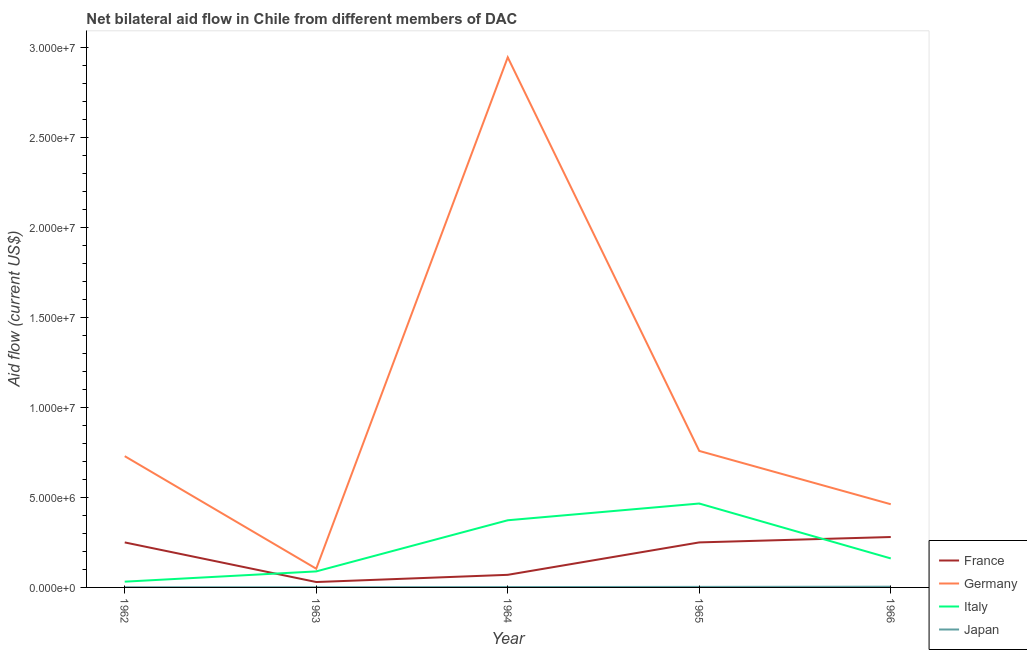Does the line corresponding to amount of aid given by italy intersect with the line corresponding to amount of aid given by germany?
Your answer should be very brief. No. Is the number of lines equal to the number of legend labels?
Ensure brevity in your answer.  Yes. What is the amount of aid given by japan in 1964?
Your answer should be very brief. 2.00e+04. Across all years, what is the maximum amount of aid given by japan?
Provide a succinct answer. 4.00e+04. Across all years, what is the minimum amount of aid given by japan?
Make the answer very short. 10000. In which year was the amount of aid given by france maximum?
Provide a succinct answer. 1966. In which year was the amount of aid given by germany minimum?
Give a very brief answer. 1963. What is the total amount of aid given by france in the graph?
Make the answer very short. 8.80e+06. What is the difference between the amount of aid given by france in 1962 and that in 1966?
Provide a succinct answer. -3.00e+05. What is the difference between the amount of aid given by germany in 1964 and the amount of aid given by italy in 1963?
Ensure brevity in your answer.  2.86e+07. What is the average amount of aid given by japan per year?
Provide a succinct answer. 2.20e+04. In the year 1966, what is the difference between the amount of aid given by france and amount of aid given by japan?
Provide a short and direct response. 2.76e+06. In how many years, is the amount of aid given by france greater than 9000000 US$?
Provide a succinct answer. 0. Is the amount of aid given by germany in 1963 less than that in 1965?
Make the answer very short. Yes. What is the difference between the highest and the second highest amount of aid given by italy?
Your response must be concise. 9.30e+05. What is the difference between the highest and the lowest amount of aid given by france?
Provide a short and direct response. 2.50e+06. In how many years, is the amount of aid given by france greater than the average amount of aid given by france taken over all years?
Ensure brevity in your answer.  3. Is the sum of the amount of aid given by france in 1963 and 1965 greater than the maximum amount of aid given by italy across all years?
Provide a short and direct response. No. Does the amount of aid given by italy monotonically increase over the years?
Your answer should be very brief. No. Is the amount of aid given by germany strictly greater than the amount of aid given by italy over the years?
Keep it short and to the point. Yes. How many lines are there?
Provide a succinct answer. 4. How many years are there in the graph?
Provide a short and direct response. 5. What is the difference between two consecutive major ticks on the Y-axis?
Your answer should be very brief. 5.00e+06. Are the values on the major ticks of Y-axis written in scientific E-notation?
Your answer should be very brief. Yes. Does the graph contain any zero values?
Keep it short and to the point. No. Does the graph contain grids?
Make the answer very short. No. How are the legend labels stacked?
Keep it short and to the point. Vertical. What is the title of the graph?
Provide a short and direct response. Net bilateral aid flow in Chile from different members of DAC. What is the label or title of the X-axis?
Give a very brief answer. Year. What is the Aid flow (current US$) in France in 1962?
Give a very brief answer. 2.50e+06. What is the Aid flow (current US$) in Germany in 1962?
Offer a very short reply. 7.29e+06. What is the Aid flow (current US$) of Japan in 1962?
Provide a succinct answer. 10000. What is the Aid flow (current US$) in France in 1963?
Your answer should be compact. 3.00e+05. What is the Aid flow (current US$) in Germany in 1963?
Your answer should be compact. 1.04e+06. What is the Aid flow (current US$) of Italy in 1963?
Ensure brevity in your answer.  8.90e+05. What is the Aid flow (current US$) in Japan in 1963?
Make the answer very short. 10000. What is the Aid flow (current US$) of Germany in 1964?
Your response must be concise. 2.94e+07. What is the Aid flow (current US$) in Italy in 1964?
Your answer should be compact. 3.73e+06. What is the Aid flow (current US$) in France in 1965?
Give a very brief answer. 2.50e+06. What is the Aid flow (current US$) of Germany in 1965?
Offer a very short reply. 7.58e+06. What is the Aid flow (current US$) of Italy in 1965?
Your answer should be compact. 4.66e+06. What is the Aid flow (current US$) in Japan in 1965?
Offer a terse response. 3.00e+04. What is the Aid flow (current US$) of France in 1966?
Provide a short and direct response. 2.80e+06. What is the Aid flow (current US$) of Germany in 1966?
Provide a succinct answer. 4.62e+06. What is the Aid flow (current US$) of Italy in 1966?
Make the answer very short. 1.61e+06. Across all years, what is the maximum Aid flow (current US$) in France?
Make the answer very short. 2.80e+06. Across all years, what is the maximum Aid flow (current US$) of Germany?
Offer a terse response. 2.94e+07. Across all years, what is the maximum Aid flow (current US$) of Italy?
Your response must be concise. 4.66e+06. Across all years, what is the minimum Aid flow (current US$) in Germany?
Offer a very short reply. 1.04e+06. What is the total Aid flow (current US$) in France in the graph?
Your response must be concise. 8.80e+06. What is the total Aid flow (current US$) in Germany in the graph?
Make the answer very short. 5.00e+07. What is the total Aid flow (current US$) of Italy in the graph?
Ensure brevity in your answer.  1.12e+07. What is the total Aid flow (current US$) in Japan in the graph?
Offer a very short reply. 1.10e+05. What is the difference between the Aid flow (current US$) in France in 1962 and that in 1963?
Your answer should be compact. 2.20e+06. What is the difference between the Aid flow (current US$) of Germany in 1962 and that in 1963?
Give a very brief answer. 6.25e+06. What is the difference between the Aid flow (current US$) of Italy in 1962 and that in 1963?
Your answer should be compact. -5.70e+05. What is the difference between the Aid flow (current US$) in France in 1962 and that in 1964?
Your answer should be compact. 1.80e+06. What is the difference between the Aid flow (current US$) in Germany in 1962 and that in 1964?
Ensure brevity in your answer.  -2.22e+07. What is the difference between the Aid flow (current US$) of Italy in 1962 and that in 1964?
Offer a terse response. -3.41e+06. What is the difference between the Aid flow (current US$) in Japan in 1962 and that in 1964?
Provide a succinct answer. -10000. What is the difference between the Aid flow (current US$) in Germany in 1962 and that in 1965?
Ensure brevity in your answer.  -2.90e+05. What is the difference between the Aid flow (current US$) of Italy in 1962 and that in 1965?
Provide a short and direct response. -4.34e+06. What is the difference between the Aid flow (current US$) of Japan in 1962 and that in 1965?
Keep it short and to the point. -2.00e+04. What is the difference between the Aid flow (current US$) in Germany in 1962 and that in 1966?
Give a very brief answer. 2.67e+06. What is the difference between the Aid flow (current US$) of Italy in 1962 and that in 1966?
Give a very brief answer. -1.29e+06. What is the difference between the Aid flow (current US$) of France in 1963 and that in 1964?
Your answer should be compact. -4.00e+05. What is the difference between the Aid flow (current US$) in Germany in 1963 and that in 1964?
Provide a succinct answer. -2.84e+07. What is the difference between the Aid flow (current US$) of Italy in 1963 and that in 1964?
Offer a terse response. -2.84e+06. What is the difference between the Aid flow (current US$) of France in 1963 and that in 1965?
Keep it short and to the point. -2.20e+06. What is the difference between the Aid flow (current US$) in Germany in 1963 and that in 1965?
Your answer should be very brief. -6.54e+06. What is the difference between the Aid flow (current US$) in Italy in 1963 and that in 1965?
Make the answer very short. -3.77e+06. What is the difference between the Aid flow (current US$) in France in 1963 and that in 1966?
Ensure brevity in your answer.  -2.50e+06. What is the difference between the Aid flow (current US$) in Germany in 1963 and that in 1966?
Provide a succinct answer. -3.58e+06. What is the difference between the Aid flow (current US$) of Italy in 1963 and that in 1966?
Your answer should be compact. -7.20e+05. What is the difference between the Aid flow (current US$) in Japan in 1963 and that in 1966?
Offer a terse response. -3.00e+04. What is the difference between the Aid flow (current US$) of France in 1964 and that in 1965?
Your answer should be compact. -1.80e+06. What is the difference between the Aid flow (current US$) of Germany in 1964 and that in 1965?
Keep it short and to the point. 2.19e+07. What is the difference between the Aid flow (current US$) in Italy in 1964 and that in 1965?
Provide a succinct answer. -9.30e+05. What is the difference between the Aid flow (current US$) in France in 1964 and that in 1966?
Give a very brief answer. -2.10e+06. What is the difference between the Aid flow (current US$) of Germany in 1964 and that in 1966?
Your response must be concise. 2.48e+07. What is the difference between the Aid flow (current US$) in Italy in 1964 and that in 1966?
Your answer should be compact. 2.12e+06. What is the difference between the Aid flow (current US$) in Japan in 1964 and that in 1966?
Provide a succinct answer. -2.00e+04. What is the difference between the Aid flow (current US$) in Germany in 1965 and that in 1966?
Ensure brevity in your answer.  2.96e+06. What is the difference between the Aid flow (current US$) in Italy in 1965 and that in 1966?
Your response must be concise. 3.05e+06. What is the difference between the Aid flow (current US$) of France in 1962 and the Aid flow (current US$) of Germany in 1963?
Provide a succinct answer. 1.46e+06. What is the difference between the Aid flow (current US$) of France in 1962 and the Aid flow (current US$) of Italy in 1963?
Offer a terse response. 1.61e+06. What is the difference between the Aid flow (current US$) of France in 1962 and the Aid flow (current US$) of Japan in 1963?
Give a very brief answer. 2.49e+06. What is the difference between the Aid flow (current US$) in Germany in 1962 and the Aid flow (current US$) in Italy in 1963?
Keep it short and to the point. 6.40e+06. What is the difference between the Aid flow (current US$) of Germany in 1962 and the Aid flow (current US$) of Japan in 1963?
Offer a terse response. 7.28e+06. What is the difference between the Aid flow (current US$) of France in 1962 and the Aid flow (current US$) of Germany in 1964?
Provide a succinct answer. -2.69e+07. What is the difference between the Aid flow (current US$) of France in 1962 and the Aid flow (current US$) of Italy in 1964?
Ensure brevity in your answer.  -1.23e+06. What is the difference between the Aid flow (current US$) in France in 1962 and the Aid flow (current US$) in Japan in 1964?
Offer a terse response. 2.48e+06. What is the difference between the Aid flow (current US$) of Germany in 1962 and the Aid flow (current US$) of Italy in 1964?
Offer a terse response. 3.56e+06. What is the difference between the Aid flow (current US$) in Germany in 1962 and the Aid flow (current US$) in Japan in 1964?
Your answer should be very brief. 7.27e+06. What is the difference between the Aid flow (current US$) of France in 1962 and the Aid flow (current US$) of Germany in 1965?
Provide a short and direct response. -5.08e+06. What is the difference between the Aid flow (current US$) in France in 1962 and the Aid flow (current US$) in Italy in 1965?
Offer a terse response. -2.16e+06. What is the difference between the Aid flow (current US$) in France in 1962 and the Aid flow (current US$) in Japan in 1965?
Offer a very short reply. 2.47e+06. What is the difference between the Aid flow (current US$) of Germany in 1962 and the Aid flow (current US$) of Italy in 1965?
Ensure brevity in your answer.  2.63e+06. What is the difference between the Aid flow (current US$) of Germany in 1962 and the Aid flow (current US$) of Japan in 1965?
Provide a succinct answer. 7.26e+06. What is the difference between the Aid flow (current US$) of France in 1962 and the Aid flow (current US$) of Germany in 1966?
Your answer should be very brief. -2.12e+06. What is the difference between the Aid flow (current US$) of France in 1962 and the Aid flow (current US$) of Italy in 1966?
Provide a short and direct response. 8.90e+05. What is the difference between the Aid flow (current US$) in France in 1962 and the Aid flow (current US$) in Japan in 1966?
Ensure brevity in your answer.  2.46e+06. What is the difference between the Aid flow (current US$) of Germany in 1962 and the Aid flow (current US$) of Italy in 1966?
Your answer should be very brief. 5.68e+06. What is the difference between the Aid flow (current US$) in Germany in 1962 and the Aid flow (current US$) in Japan in 1966?
Provide a short and direct response. 7.25e+06. What is the difference between the Aid flow (current US$) in Italy in 1962 and the Aid flow (current US$) in Japan in 1966?
Make the answer very short. 2.80e+05. What is the difference between the Aid flow (current US$) in France in 1963 and the Aid flow (current US$) in Germany in 1964?
Your answer should be very brief. -2.91e+07. What is the difference between the Aid flow (current US$) of France in 1963 and the Aid flow (current US$) of Italy in 1964?
Offer a terse response. -3.43e+06. What is the difference between the Aid flow (current US$) in Germany in 1963 and the Aid flow (current US$) in Italy in 1964?
Your answer should be compact. -2.69e+06. What is the difference between the Aid flow (current US$) of Germany in 1963 and the Aid flow (current US$) of Japan in 1964?
Provide a short and direct response. 1.02e+06. What is the difference between the Aid flow (current US$) of Italy in 1963 and the Aid flow (current US$) of Japan in 1964?
Give a very brief answer. 8.70e+05. What is the difference between the Aid flow (current US$) of France in 1963 and the Aid flow (current US$) of Germany in 1965?
Provide a short and direct response. -7.28e+06. What is the difference between the Aid flow (current US$) in France in 1963 and the Aid flow (current US$) in Italy in 1965?
Provide a short and direct response. -4.36e+06. What is the difference between the Aid flow (current US$) in France in 1963 and the Aid flow (current US$) in Japan in 1965?
Offer a very short reply. 2.70e+05. What is the difference between the Aid flow (current US$) of Germany in 1963 and the Aid flow (current US$) of Italy in 1965?
Offer a terse response. -3.62e+06. What is the difference between the Aid flow (current US$) of Germany in 1963 and the Aid flow (current US$) of Japan in 1965?
Keep it short and to the point. 1.01e+06. What is the difference between the Aid flow (current US$) of Italy in 1963 and the Aid flow (current US$) of Japan in 1965?
Your answer should be compact. 8.60e+05. What is the difference between the Aid flow (current US$) of France in 1963 and the Aid flow (current US$) of Germany in 1966?
Provide a succinct answer. -4.32e+06. What is the difference between the Aid flow (current US$) of France in 1963 and the Aid flow (current US$) of Italy in 1966?
Provide a short and direct response. -1.31e+06. What is the difference between the Aid flow (current US$) of France in 1963 and the Aid flow (current US$) of Japan in 1966?
Your answer should be compact. 2.60e+05. What is the difference between the Aid flow (current US$) of Germany in 1963 and the Aid flow (current US$) of Italy in 1966?
Provide a short and direct response. -5.70e+05. What is the difference between the Aid flow (current US$) in Italy in 1963 and the Aid flow (current US$) in Japan in 1966?
Give a very brief answer. 8.50e+05. What is the difference between the Aid flow (current US$) of France in 1964 and the Aid flow (current US$) of Germany in 1965?
Keep it short and to the point. -6.88e+06. What is the difference between the Aid flow (current US$) in France in 1964 and the Aid flow (current US$) in Italy in 1965?
Your answer should be compact. -3.96e+06. What is the difference between the Aid flow (current US$) in France in 1964 and the Aid flow (current US$) in Japan in 1965?
Your answer should be very brief. 6.70e+05. What is the difference between the Aid flow (current US$) of Germany in 1964 and the Aid flow (current US$) of Italy in 1965?
Your response must be concise. 2.48e+07. What is the difference between the Aid flow (current US$) of Germany in 1964 and the Aid flow (current US$) of Japan in 1965?
Your response must be concise. 2.94e+07. What is the difference between the Aid flow (current US$) of Italy in 1964 and the Aid flow (current US$) of Japan in 1965?
Your answer should be compact. 3.70e+06. What is the difference between the Aid flow (current US$) of France in 1964 and the Aid flow (current US$) of Germany in 1966?
Offer a very short reply. -3.92e+06. What is the difference between the Aid flow (current US$) in France in 1964 and the Aid flow (current US$) in Italy in 1966?
Keep it short and to the point. -9.10e+05. What is the difference between the Aid flow (current US$) in Germany in 1964 and the Aid flow (current US$) in Italy in 1966?
Keep it short and to the point. 2.78e+07. What is the difference between the Aid flow (current US$) of Germany in 1964 and the Aid flow (current US$) of Japan in 1966?
Your response must be concise. 2.94e+07. What is the difference between the Aid flow (current US$) in Italy in 1964 and the Aid flow (current US$) in Japan in 1966?
Your answer should be compact. 3.69e+06. What is the difference between the Aid flow (current US$) in France in 1965 and the Aid flow (current US$) in Germany in 1966?
Provide a short and direct response. -2.12e+06. What is the difference between the Aid flow (current US$) in France in 1965 and the Aid flow (current US$) in Italy in 1966?
Give a very brief answer. 8.90e+05. What is the difference between the Aid flow (current US$) of France in 1965 and the Aid flow (current US$) of Japan in 1966?
Offer a very short reply. 2.46e+06. What is the difference between the Aid flow (current US$) in Germany in 1965 and the Aid flow (current US$) in Italy in 1966?
Provide a short and direct response. 5.97e+06. What is the difference between the Aid flow (current US$) of Germany in 1965 and the Aid flow (current US$) of Japan in 1966?
Your response must be concise. 7.54e+06. What is the difference between the Aid flow (current US$) in Italy in 1965 and the Aid flow (current US$) in Japan in 1966?
Your response must be concise. 4.62e+06. What is the average Aid flow (current US$) in France per year?
Keep it short and to the point. 1.76e+06. What is the average Aid flow (current US$) in Germany per year?
Make the answer very short. 9.99e+06. What is the average Aid flow (current US$) in Italy per year?
Give a very brief answer. 2.24e+06. What is the average Aid flow (current US$) in Japan per year?
Give a very brief answer. 2.20e+04. In the year 1962, what is the difference between the Aid flow (current US$) in France and Aid flow (current US$) in Germany?
Give a very brief answer. -4.79e+06. In the year 1962, what is the difference between the Aid flow (current US$) in France and Aid flow (current US$) in Italy?
Offer a terse response. 2.18e+06. In the year 1962, what is the difference between the Aid flow (current US$) in France and Aid flow (current US$) in Japan?
Offer a terse response. 2.49e+06. In the year 1962, what is the difference between the Aid flow (current US$) of Germany and Aid flow (current US$) of Italy?
Make the answer very short. 6.97e+06. In the year 1962, what is the difference between the Aid flow (current US$) in Germany and Aid flow (current US$) in Japan?
Make the answer very short. 7.28e+06. In the year 1962, what is the difference between the Aid flow (current US$) of Italy and Aid flow (current US$) of Japan?
Offer a terse response. 3.10e+05. In the year 1963, what is the difference between the Aid flow (current US$) of France and Aid flow (current US$) of Germany?
Your response must be concise. -7.40e+05. In the year 1963, what is the difference between the Aid flow (current US$) in France and Aid flow (current US$) in Italy?
Your answer should be compact. -5.90e+05. In the year 1963, what is the difference between the Aid flow (current US$) in Germany and Aid flow (current US$) in Japan?
Give a very brief answer. 1.03e+06. In the year 1963, what is the difference between the Aid flow (current US$) of Italy and Aid flow (current US$) of Japan?
Your answer should be very brief. 8.80e+05. In the year 1964, what is the difference between the Aid flow (current US$) of France and Aid flow (current US$) of Germany?
Make the answer very short. -2.87e+07. In the year 1964, what is the difference between the Aid flow (current US$) of France and Aid flow (current US$) of Italy?
Your answer should be very brief. -3.03e+06. In the year 1964, what is the difference between the Aid flow (current US$) in France and Aid flow (current US$) in Japan?
Offer a very short reply. 6.80e+05. In the year 1964, what is the difference between the Aid flow (current US$) of Germany and Aid flow (current US$) of Italy?
Ensure brevity in your answer.  2.57e+07. In the year 1964, what is the difference between the Aid flow (current US$) in Germany and Aid flow (current US$) in Japan?
Your answer should be compact. 2.94e+07. In the year 1964, what is the difference between the Aid flow (current US$) of Italy and Aid flow (current US$) of Japan?
Your answer should be very brief. 3.71e+06. In the year 1965, what is the difference between the Aid flow (current US$) of France and Aid flow (current US$) of Germany?
Ensure brevity in your answer.  -5.08e+06. In the year 1965, what is the difference between the Aid flow (current US$) in France and Aid flow (current US$) in Italy?
Make the answer very short. -2.16e+06. In the year 1965, what is the difference between the Aid flow (current US$) in France and Aid flow (current US$) in Japan?
Offer a very short reply. 2.47e+06. In the year 1965, what is the difference between the Aid flow (current US$) of Germany and Aid flow (current US$) of Italy?
Your answer should be very brief. 2.92e+06. In the year 1965, what is the difference between the Aid flow (current US$) in Germany and Aid flow (current US$) in Japan?
Make the answer very short. 7.55e+06. In the year 1965, what is the difference between the Aid flow (current US$) in Italy and Aid flow (current US$) in Japan?
Keep it short and to the point. 4.63e+06. In the year 1966, what is the difference between the Aid flow (current US$) in France and Aid flow (current US$) in Germany?
Ensure brevity in your answer.  -1.82e+06. In the year 1966, what is the difference between the Aid flow (current US$) of France and Aid flow (current US$) of Italy?
Offer a terse response. 1.19e+06. In the year 1966, what is the difference between the Aid flow (current US$) in France and Aid flow (current US$) in Japan?
Provide a succinct answer. 2.76e+06. In the year 1966, what is the difference between the Aid flow (current US$) in Germany and Aid flow (current US$) in Italy?
Provide a short and direct response. 3.01e+06. In the year 1966, what is the difference between the Aid flow (current US$) of Germany and Aid flow (current US$) of Japan?
Provide a succinct answer. 4.58e+06. In the year 1966, what is the difference between the Aid flow (current US$) in Italy and Aid flow (current US$) in Japan?
Keep it short and to the point. 1.57e+06. What is the ratio of the Aid flow (current US$) in France in 1962 to that in 1963?
Offer a very short reply. 8.33. What is the ratio of the Aid flow (current US$) of Germany in 1962 to that in 1963?
Your answer should be compact. 7.01. What is the ratio of the Aid flow (current US$) of Italy in 1962 to that in 1963?
Ensure brevity in your answer.  0.36. What is the ratio of the Aid flow (current US$) of France in 1962 to that in 1964?
Offer a very short reply. 3.57. What is the ratio of the Aid flow (current US$) in Germany in 1962 to that in 1964?
Ensure brevity in your answer.  0.25. What is the ratio of the Aid flow (current US$) of Italy in 1962 to that in 1964?
Your response must be concise. 0.09. What is the ratio of the Aid flow (current US$) of Japan in 1962 to that in 1964?
Your response must be concise. 0.5. What is the ratio of the Aid flow (current US$) of France in 1962 to that in 1965?
Provide a succinct answer. 1. What is the ratio of the Aid flow (current US$) in Germany in 1962 to that in 1965?
Your answer should be compact. 0.96. What is the ratio of the Aid flow (current US$) of Italy in 1962 to that in 1965?
Your answer should be very brief. 0.07. What is the ratio of the Aid flow (current US$) in France in 1962 to that in 1966?
Your answer should be compact. 0.89. What is the ratio of the Aid flow (current US$) of Germany in 1962 to that in 1966?
Your response must be concise. 1.58. What is the ratio of the Aid flow (current US$) in Italy in 1962 to that in 1966?
Offer a terse response. 0.2. What is the ratio of the Aid flow (current US$) of France in 1963 to that in 1964?
Your answer should be compact. 0.43. What is the ratio of the Aid flow (current US$) in Germany in 1963 to that in 1964?
Ensure brevity in your answer.  0.04. What is the ratio of the Aid flow (current US$) of Italy in 1963 to that in 1964?
Offer a terse response. 0.24. What is the ratio of the Aid flow (current US$) of France in 1963 to that in 1965?
Offer a very short reply. 0.12. What is the ratio of the Aid flow (current US$) of Germany in 1963 to that in 1965?
Your answer should be very brief. 0.14. What is the ratio of the Aid flow (current US$) of Italy in 1963 to that in 1965?
Keep it short and to the point. 0.19. What is the ratio of the Aid flow (current US$) of Japan in 1963 to that in 1965?
Your response must be concise. 0.33. What is the ratio of the Aid flow (current US$) of France in 1963 to that in 1966?
Keep it short and to the point. 0.11. What is the ratio of the Aid flow (current US$) in Germany in 1963 to that in 1966?
Your answer should be compact. 0.23. What is the ratio of the Aid flow (current US$) in Italy in 1963 to that in 1966?
Give a very brief answer. 0.55. What is the ratio of the Aid flow (current US$) of Japan in 1963 to that in 1966?
Offer a terse response. 0.25. What is the ratio of the Aid flow (current US$) of France in 1964 to that in 1965?
Give a very brief answer. 0.28. What is the ratio of the Aid flow (current US$) in Germany in 1964 to that in 1965?
Keep it short and to the point. 3.88. What is the ratio of the Aid flow (current US$) of Italy in 1964 to that in 1965?
Keep it short and to the point. 0.8. What is the ratio of the Aid flow (current US$) in France in 1964 to that in 1966?
Offer a terse response. 0.25. What is the ratio of the Aid flow (current US$) in Germany in 1964 to that in 1966?
Give a very brief answer. 6.37. What is the ratio of the Aid flow (current US$) in Italy in 1964 to that in 1966?
Offer a very short reply. 2.32. What is the ratio of the Aid flow (current US$) of Japan in 1964 to that in 1966?
Make the answer very short. 0.5. What is the ratio of the Aid flow (current US$) of France in 1965 to that in 1966?
Keep it short and to the point. 0.89. What is the ratio of the Aid flow (current US$) in Germany in 1965 to that in 1966?
Your response must be concise. 1.64. What is the ratio of the Aid flow (current US$) of Italy in 1965 to that in 1966?
Provide a short and direct response. 2.89. What is the ratio of the Aid flow (current US$) of Japan in 1965 to that in 1966?
Your answer should be very brief. 0.75. What is the difference between the highest and the second highest Aid flow (current US$) in Germany?
Keep it short and to the point. 2.19e+07. What is the difference between the highest and the second highest Aid flow (current US$) in Italy?
Your answer should be very brief. 9.30e+05. What is the difference between the highest and the second highest Aid flow (current US$) in Japan?
Give a very brief answer. 10000. What is the difference between the highest and the lowest Aid flow (current US$) of France?
Your answer should be very brief. 2.50e+06. What is the difference between the highest and the lowest Aid flow (current US$) of Germany?
Give a very brief answer. 2.84e+07. What is the difference between the highest and the lowest Aid flow (current US$) of Italy?
Offer a very short reply. 4.34e+06. 